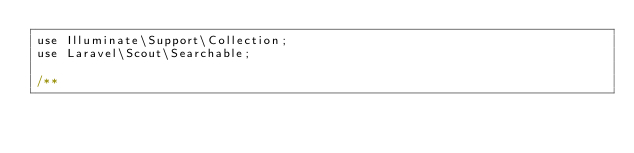<code> <loc_0><loc_0><loc_500><loc_500><_PHP_>use Illuminate\Support\Collection;
use Laravel\Scout\Searchable;

/**</code> 